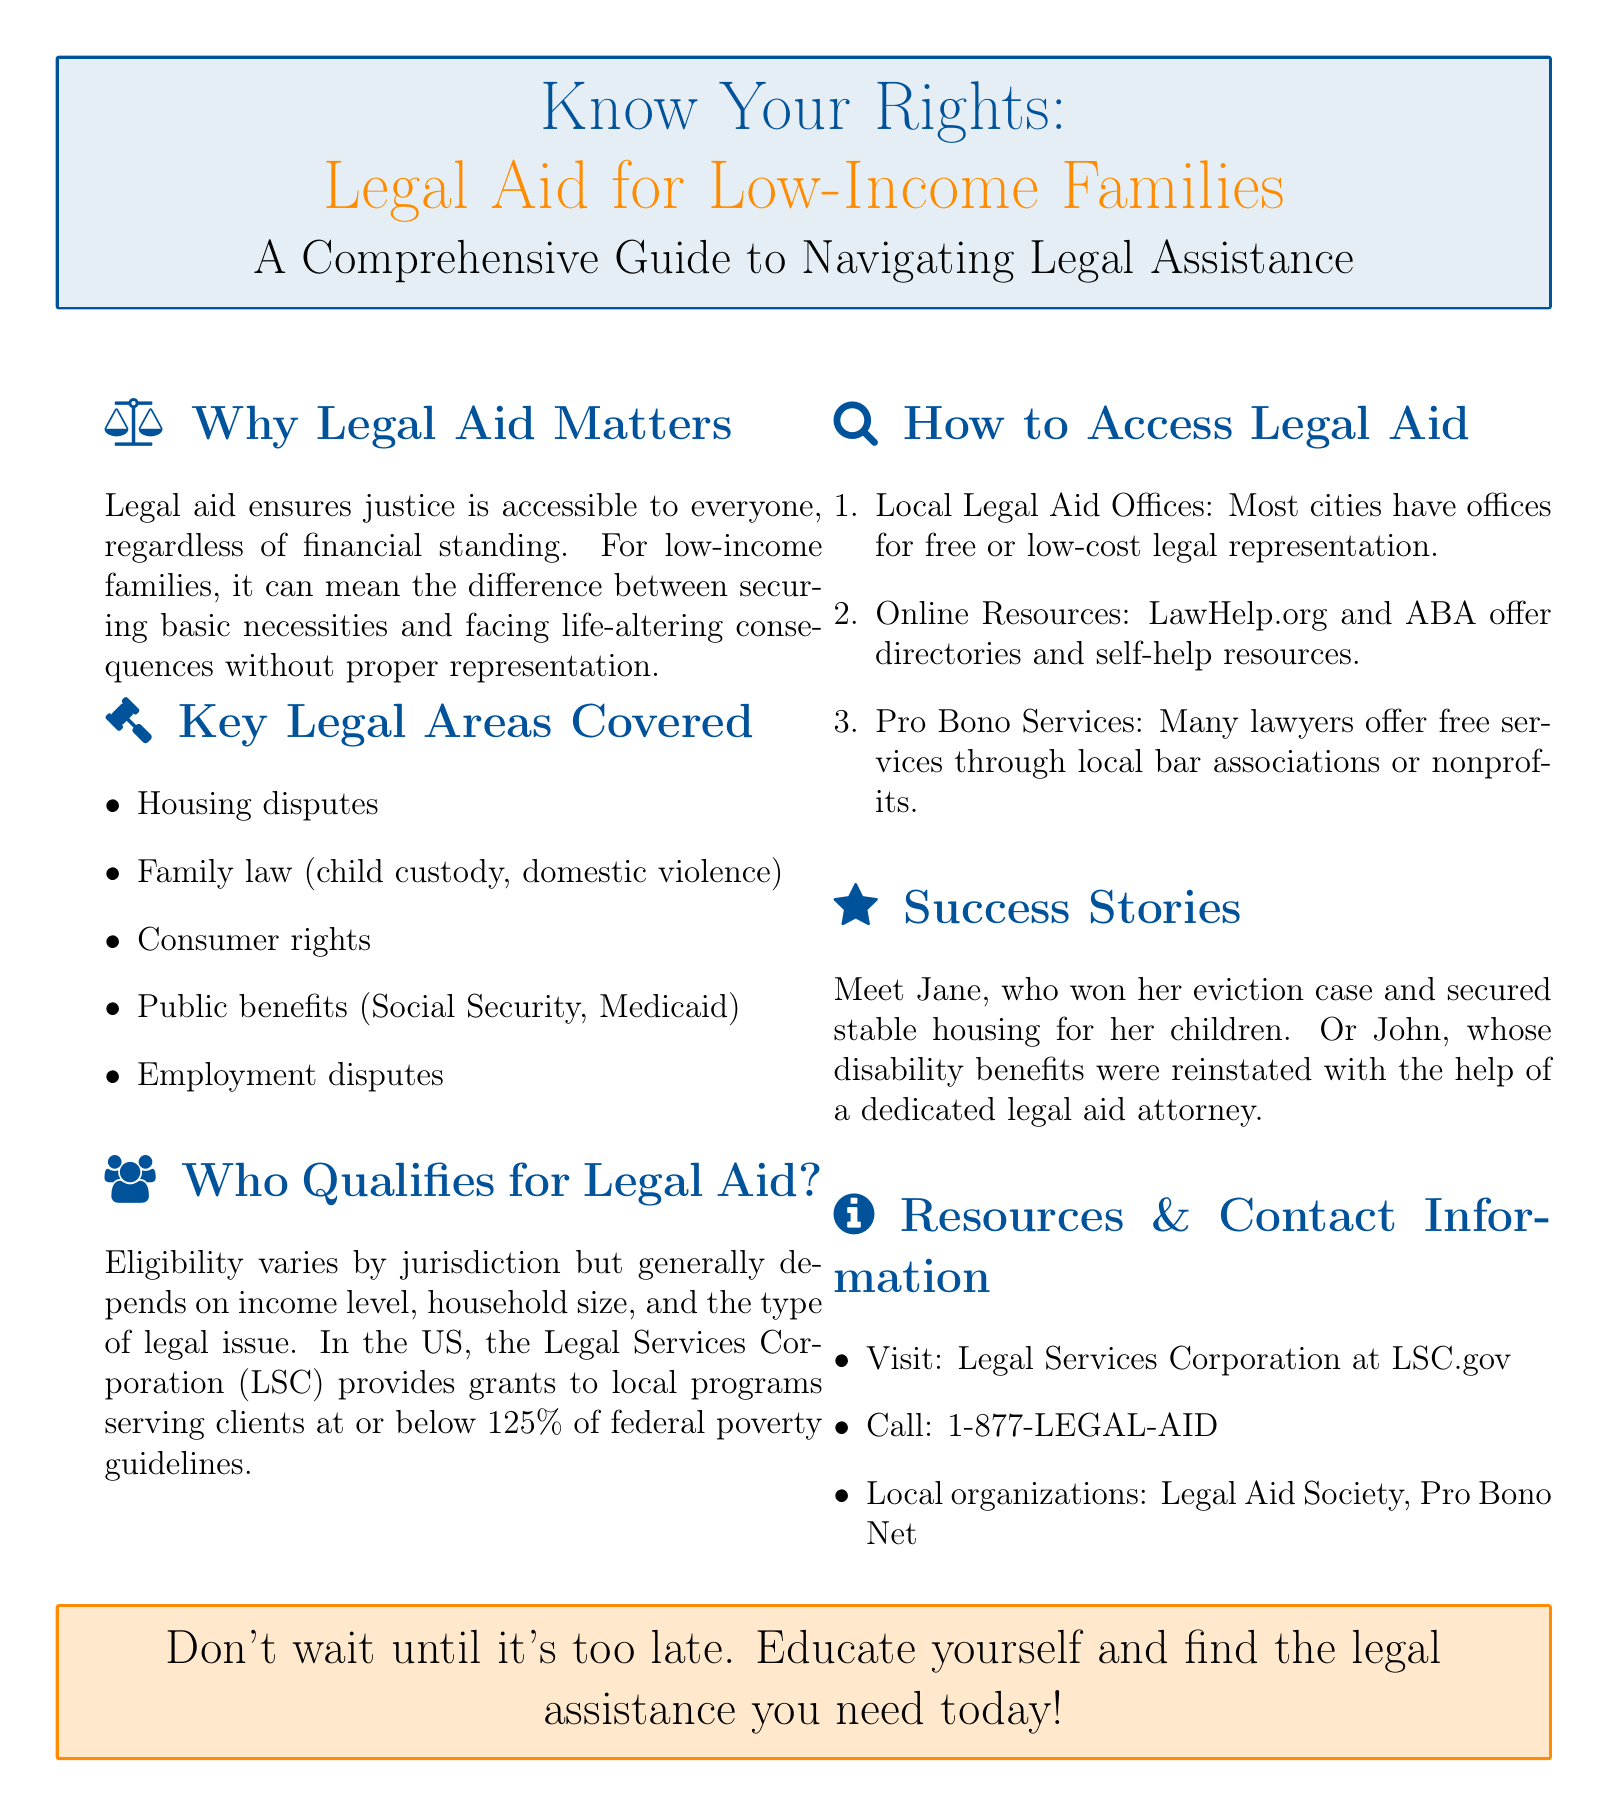What is the purpose of legal aid? The document states that legal aid ensures justice is accessible to everyone, especially low-income families.
Answer: Accessible justice Which organization provides grants for legal services? The document mentions the Legal Services Corporation (LSC) as the provider of grants to local programs.
Answer: Legal Services Corporation (LSC) What is one key area covered by legal aid? The document lists several key areas, one of which is housing disputes.
Answer: Housing disputes Who can benefit from legal aid? The document indicates that eligibility generally depends on income level and household size.
Answer: Low-income families What number can be called for legal aid assistance? The document provides a phone number for legal assistance, which is 1-877-LEGAL-AID.
Answer: 1-877-LEGAL-AID How can legal aid be accessed? The document lists several ways to access legal aid, including local legal aid offices and online resources.
Answer: Local legal aid offices What is a success story mentioned in the document? The document recounts Jane winning her eviction case as one success story.
Answer: Jane won her eviction case 